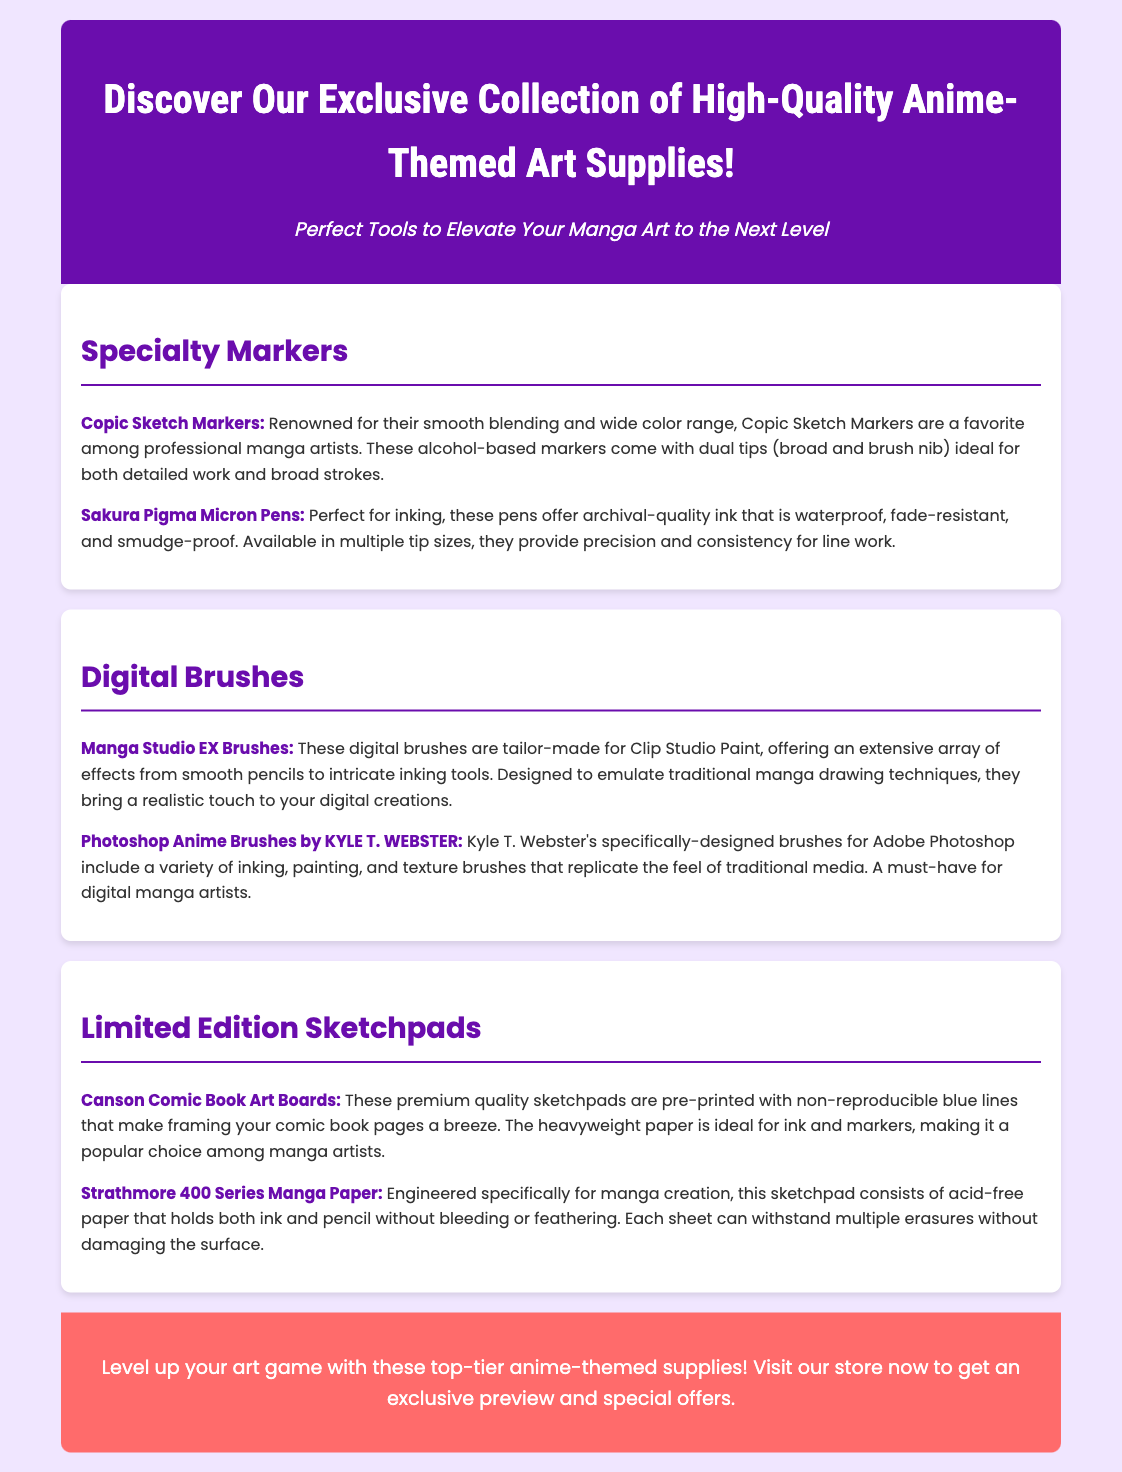What type of markers are highlighted in the advertisement? The document mentions specialty markers, specifically Copic Sketch Markers and Sakura Pigma Micron Pens.
Answer: Copic Sketch Markers What makes Copic Sketch Markers a favorite among manga artists? The document states that they are renowned for their smooth blending and wide color range.
Answer: Smooth blending and wide color range Which digital brushes are tailored for Clip Studio Paint? The advertisement lists Manga Studio EX Brushes as specifically designed for this software.
Answer: Manga Studio EX Brushes What paper quality is used in Strathmore 400 Series Manga Paper? The document describes it as acid-free paper that holds ink and pencil without bleeding or feathering.
Answer: Acid-free What is one feature of Canson Comic Book Art Boards? According to the document, they are pre-printed with non-reproducible blue lines.
Answer: Non-reproducible blue lines What is the purpose of the limited edition sketchpads? The document aims to provide a popular choice among manga artists for sketching and framing comic book pages.
Answer: Sketching and framing How does the advertisement encourage readers to take action? The call-to-action section urges readers to visit the store for an exclusive preview and special offers.
Answer: Visit our store now What kind of supplies are being advertised? The document introduces high-quality anime-themed art supplies for manga artists.
Answer: Anime-themed art supplies What can be used for inking according to the document? The advertisement mentions Sakura Pigma Micron Pens as perfect for inking.
Answer: Sakura Pigma Micron Pens 